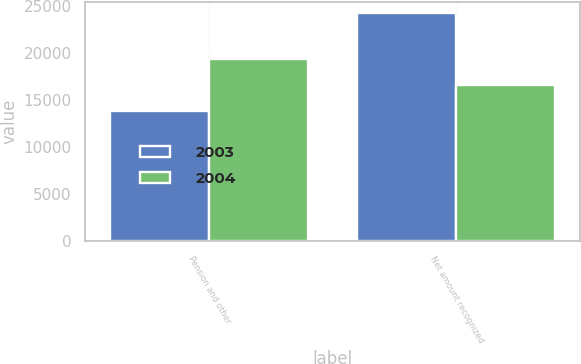Convert chart. <chart><loc_0><loc_0><loc_500><loc_500><stacked_bar_chart><ecel><fcel>Pension and other<fcel>Net amount recognized<nl><fcel>2003<fcel>13813<fcel>24156<nl><fcel>2004<fcel>19323<fcel>16585<nl></chart> 